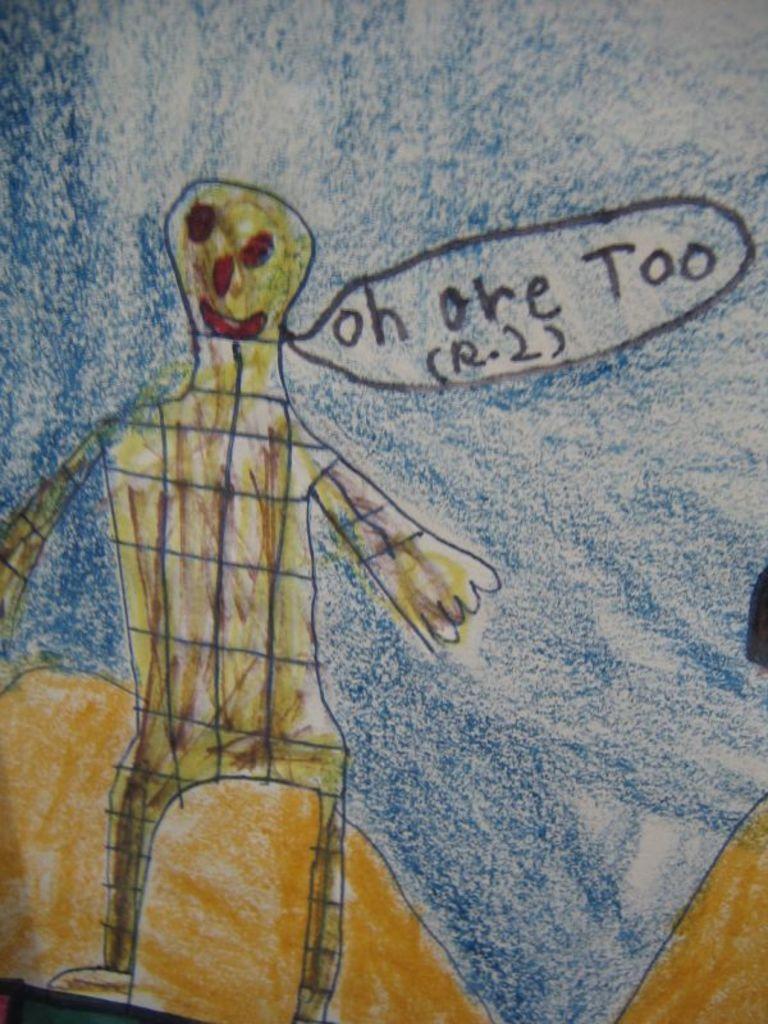In one or two sentences, can you explain what this image depicts? In this image, this looks like a drawing. I think this is a person. Here is the hill and a sky. 